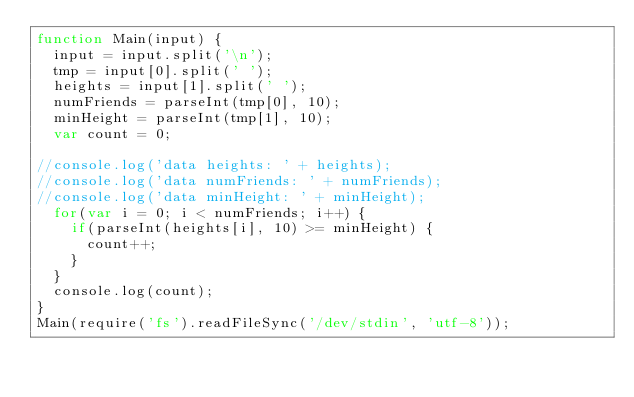<code> <loc_0><loc_0><loc_500><loc_500><_JavaScript_>function Main(input) {
  input = input.split('\n');
  tmp = input[0].split(' ');
  heights = input[1].split(' ');
  numFriends = parseInt(tmp[0], 10);
  minHeight = parseInt(tmp[1], 10); 
  var count = 0;

//console.log('data heights: ' + heights);
//console.log('data numFriends: ' + numFriends);
//console.log('data minHeight: ' + minHeight);
  for(var i = 0; i < numFriends; i++) {
    if(parseInt(heights[i], 10) >= minHeight) {
      count++;
    }
  }
  console.log(count);
}
Main(require('fs').readFileSync('/dev/stdin', 'utf-8'));
</code> 